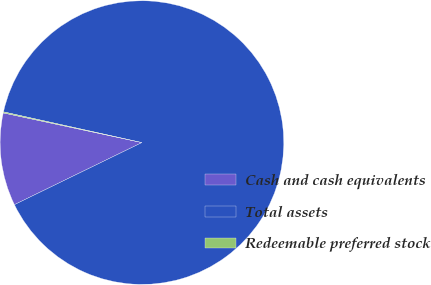Convert chart. <chart><loc_0><loc_0><loc_500><loc_500><pie_chart><fcel>Cash and cash equivalents<fcel>Total assets<fcel>Redeemable preferred stock<nl><fcel>10.57%<fcel>89.32%<fcel>0.12%<nl></chart> 